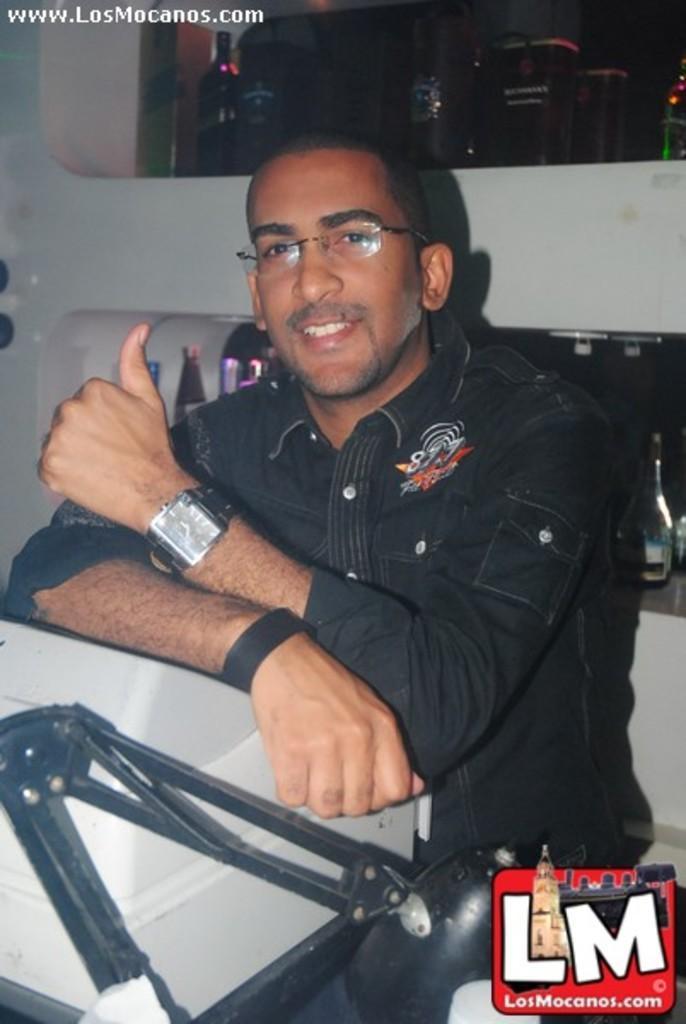How would you summarize this image in a sentence or two? In this image, we can see a man sitting and he is wearing specs and a watch, in the background there are some bottles, we can see a white color object. 